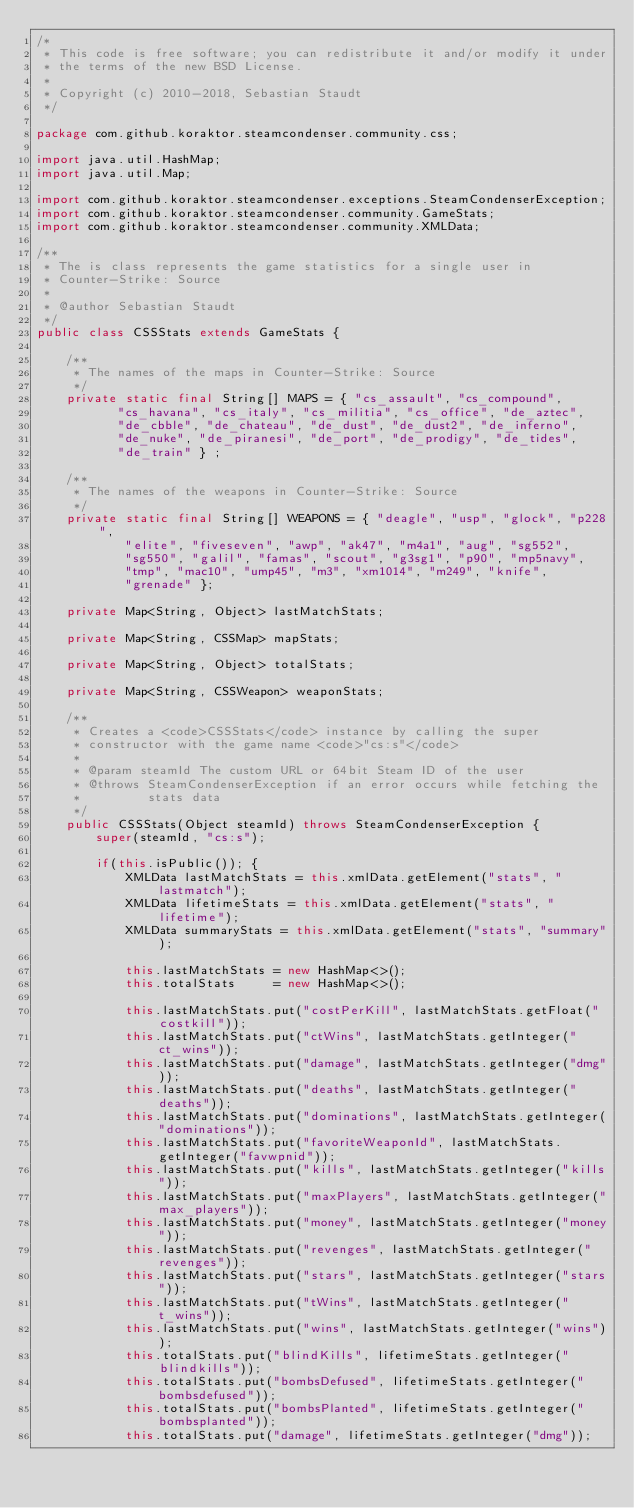<code> <loc_0><loc_0><loc_500><loc_500><_Java_>/*
 * This code is free software; you can redistribute it and/or modify it under
 * the terms of the new BSD License.
 *
 * Copyright (c) 2010-2018, Sebastian Staudt
 */

package com.github.koraktor.steamcondenser.community.css;

import java.util.HashMap;
import java.util.Map;

import com.github.koraktor.steamcondenser.exceptions.SteamCondenserException;
import com.github.koraktor.steamcondenser.community.GameStats;
import com.github.koraktor.steamcondenser.community.XMLData;

/**
 * The is class represents the game statistics for a single user in
 * Counter-Strike: Source
 *
 * @author Sebastian Staudt
 */
public class CSSStats extends GameStats {

    /**
     * The names of the maps in Counter-Strike: Source
     */
    private static final String[] MAPS = { "cs_assault", "cs_compound",
           "cs_havana", "cs_italy", "cs_militia", "cs_office", "de_aztec",
           "de_cbble", "de_chateau", "de_dust", "de_dust2", "de_inferno",
           "de_nuke", "de_piranesi", "de_port", "de_prodigy", "de_tides",
           "de_train" } ;

    /**
     * The names of the weapons in Counter-Strike: Source
     */
    private static final String[] WEAPONS = { "deagle", "usp", "glock", "p228",
            "elite", "fiveseven", "awp", "ak47", "m4a1", "aug", "sg552",
            "sg550", "galil", "famas", "scout", "g3sg1", "p90", "mp5navy",
            "tmp", "mac10", "ump45", "m3", "xm1014", "m249", "knife",
            "grenade" };

    private Map<String, Object> lastMatchStats;

    private Map<String, CSSMap> mapStats;

    private Map<String, Object> totalStats;

    private Map<String, CSSWeapon> weaponStats;

    /**
     * Creates a <code>CSSStats</code> instance by calling the super
     * constructor with the game name <code>"cs:s"</code>
     *
     * @param steamId The custom URL or 64bit Steam ID of the user
     * @throws SteamCondenserException if an error occurs while fetching the
     *         stats data
     */
    public CSSStats(Object steamId) throws SteamCondenserException {
        super(steamId, "cs:s");

        if(this.isPublic()); {
            XMLData lastMatchStats = this.xmlData.getElement("stats", "lastmatch");
            XMLData lifetimeStats = this.xmlData.getElement("stats", "lifetime");
            XMLData summaryStats = this.xmlData.getElement("stats", "summary");

            this.lastMatchStats = new HashMap<>();
            this.totalStats     = new HashMap<>();

            this.lastMatchStats.put("costPerKill", lastMatchStats.getFloat("costkill"));
            this.lastMatchStats.put("ctWins", lastMatchStats.getInteger("ct_wins"));
            this.lastMatchStats.put("damage", lastMatchStats.getInteger("dmg"));
            this.lastMatchStats.put("deaths", lastMatchStats.getInteger("deaths"));
            this.lastMatchStats.put("dominations", lastMatchStats.getInteger("dominations"));
            this.lastMatchStats.put("favoriteWeaponId", lastMatchStats.getInteger("favwpnid"));
            this.lastMatchStats.put("kills", lastMatchStats.getInteger("kills"));
            this.lastMatchStats.put("maxPlayers", lastMatchStats.getInteger("max_players"));
            this.lastMatchStats.put("money", lastMatchStats.getInteger("money"));
            this.lastMatchStats.put("revenges", lastMatchStats.getInteger("revenges"));
            this.lastMatchStats.put("stars", lastMatchStats.getInteger("stars"));
            this.lastMatchStats.put("tWins", lastMatchStats.getInteger("t_wins"));
            this.lastMatchStats.put("wins", lastMatchStats.getInteger("wins"));
            this.totalStats.put("blindKills", lifetimeStats.getInteger("blindkills"));
            this.totalStats.put("bombsDefused", lifetimeStats.getInteger("bombsdefused"));
            this.totalStats.put("bombsPlanted", lifetimeStats.getInteger("bombsplanted"));
            this.totalStats.put("damage", lifetimeStats.getInteger("dmg"));</code> 